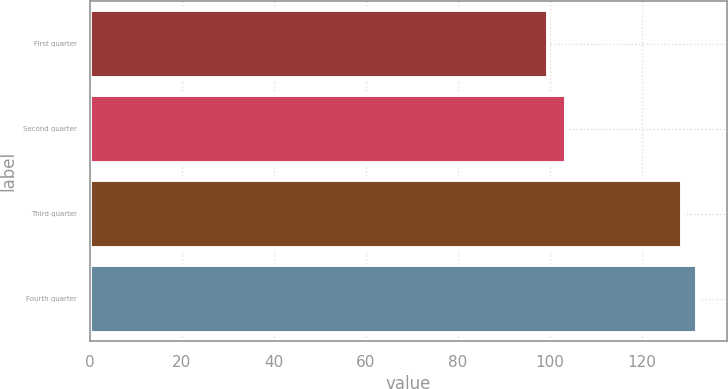<chart> <loc_0><loc_0><loc_500><loc_500><bar_chart><fcel>First quarter<fcel>Second quarter<fcel>Third quarter<fcel>Fourth quarter<nl><fcel>99.66<fcel>103.47<fcel>128.85<fcel>132.03<nl></chart> 